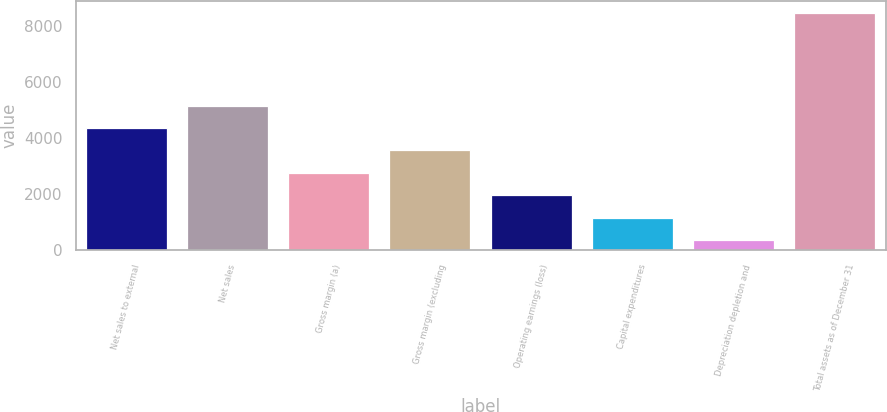<chart> <loc_0><loc_0><loc_500><loc_500><bar_chart><fcel>Net sales to external<fcel>Net sales<fcel>Gross margin (a)<fcel>Gross margin (excluding<fcel>Operating earnings (loss)<fcel>Capital expenditures<fcel>Depreciation depletion and<fcel>Total assets as of December 31<nl><fcel>4364.75<fcel>5165.76<fcel>2762.73<fcel>3563.74<fcel>1961.72<fcel>1160.71<fcel>359.7<fcel>8480.71<nl></chart> 